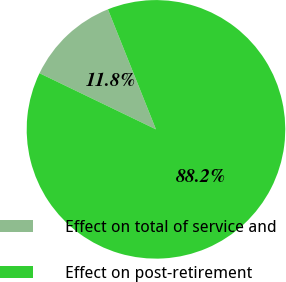Convert chart to OTSL. <chart><loc_0><loc_0><loc_500><loc_500><pie_chart><fcel>Effect on total of service and<fcel>Effect on post-retirement<nl><fcel>11.79%<fcel>88.21%<nl></chart> 